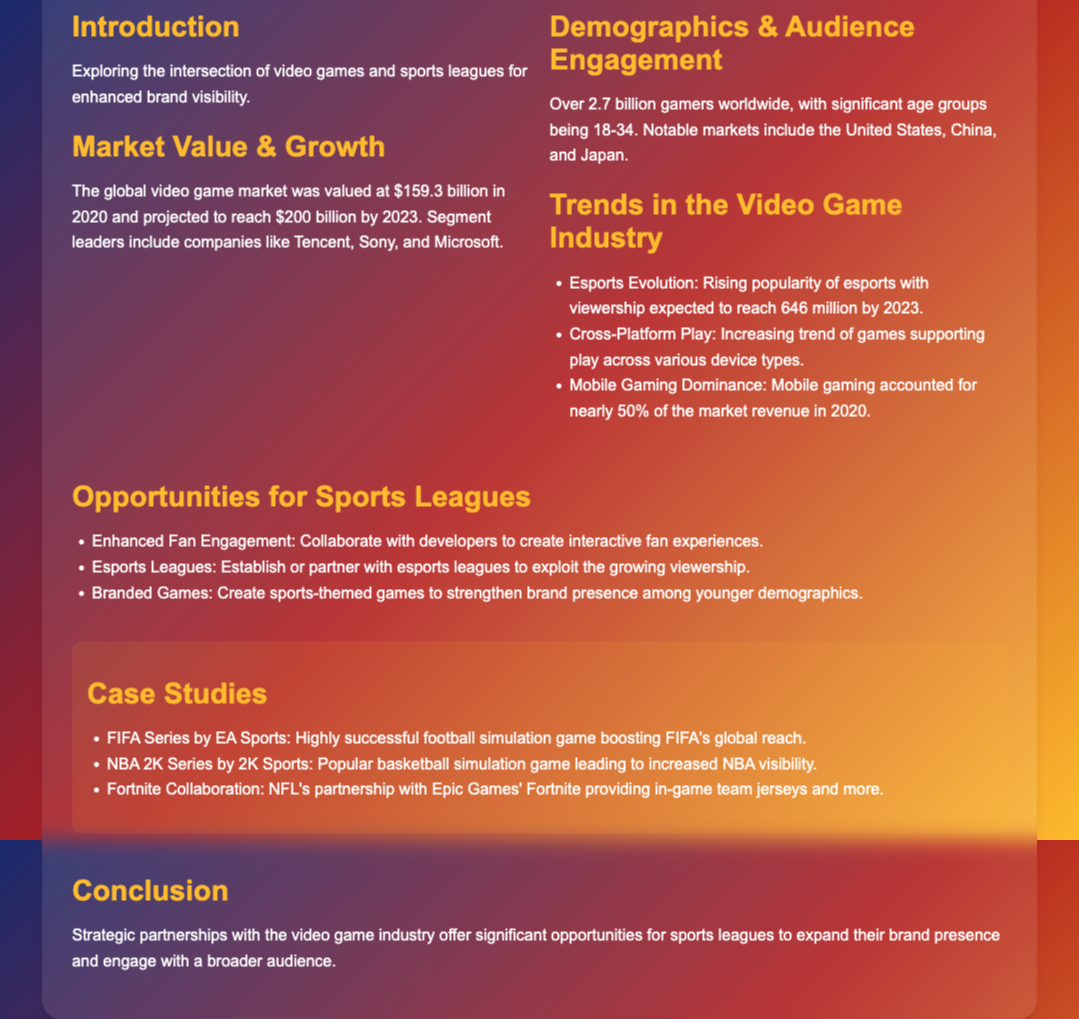What is the projected market value of the video game industry by 2023? The document states that the global video game market is projected to reach $200 billion by 2023.
Answer: $200 billion How many gamers are there worldwide? The document mentions that there are over 2.7 billion gamers worldwide.
Answer: 2.7 billion What age group constitutes a significant portion of the gaming audience? The significant age group mentioned in the document is 18-34.
Answer: 18-34 What is the expected viewership for esports by 2023? The document indicates that esports viewership is expected to reach 646 million by 2023.
Answer: 646 million Which company is associated with the FIFA series? The document identifies EA Sports as the creator of the FIFA series.
Answer: EA Sports What opportunity is suggested for enhancing fan engagement? The document recommends collaborating with developers to create interactive fan experiences.
Answer: Interactive fan experiences What is one trend in mobile gaming mentioned in the document? The document highlights that mobile gaming accounted for nearly 50% of the market revenue in 2020.
Answer: Nearly 50% Which sports league is mentioned in relation to Fortnite? The document references the NFL's partnership with Epic Games' Fortnite.
Answer: NFL What is one case study mentioned related to basketball? The NBA 2K Series by 2K Sports is mentioned as a successful case study for basketball.
Answer: NBA 2K Series 